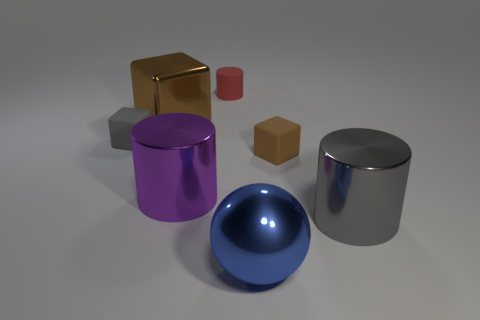The brown rubber thing that is the same size as the red rubber cylinder is what shape?
Offer a terse response. Cube. There is a metallic cylinder that is to the right of the purple object; what is its color?
Keep it short and to the point. Gray. There is a brown cube that is the same size as the gray block; what is its material?
Provide a short and direct response. Rubber. How many other things are there of the same material as the purple object?
Your answer should be very brief. 3. What is the color of the big shiny thing that is both on the right side of the small red thing and behind the big blue ball?
Your response must be concise. Gray. How many things are small blocks to the left of the purple shiny cylinder or blue metallic things?
Offer a terse response. 2. How many other objects are the same color as the tiny matte cylinder?
Offer a very short reply. 0. Is the number of things right of the small matte cylinder the same as the number of tiny matte objects?
Make the answer very short. Yes. There is a large thing that is to the right of the brown block that is in front of the big brown shiny block; what number of large blue metal objects are to the left of it?
Offer a very short reply. 1. Do the brown metallic block and the blue shiny object in front of the big metal cube have the same size?
Give a very brief answer. Yes. 